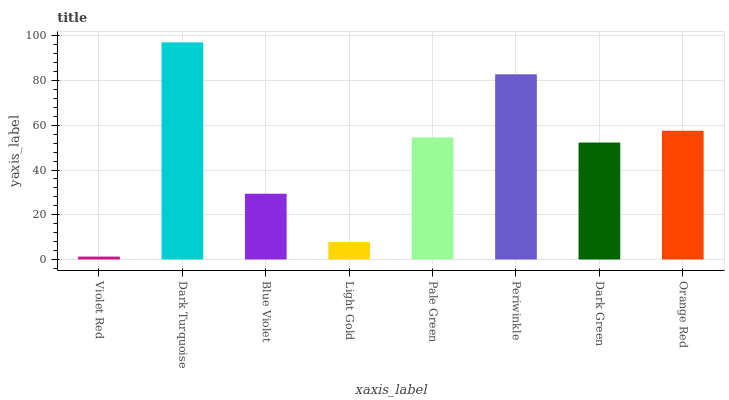Is Violet Red the minimum?
Answer yes or no. Yes. Is Dark Turquoise the maximum?
Answer yes or no. Yes. Is Blue Violet the minimum?
Answer yes or no. No. Is Blue Violet the maximum?
Answer yes or no. No. Is Dark Turquoise greater than Blue Violet?
Answer yes or no. Yes. Is Blue Violet less than Dark Turquoise?
Answer yes or no. Yes. Is Blue Violet greater than Dark Turquoise?
Answer yes or no. No. Is Dark Turquoise less than Blue Violet?
Answer yes or no. No. Is Pale Green the high median?
Answer yes or no. Yes. Is Dark Green the low median?
Answer yes or no. Yes. Is Blue Violet the high median?
Answer yes or no. No. Is Blue Violet the low median?
Answer yes or no. No. 